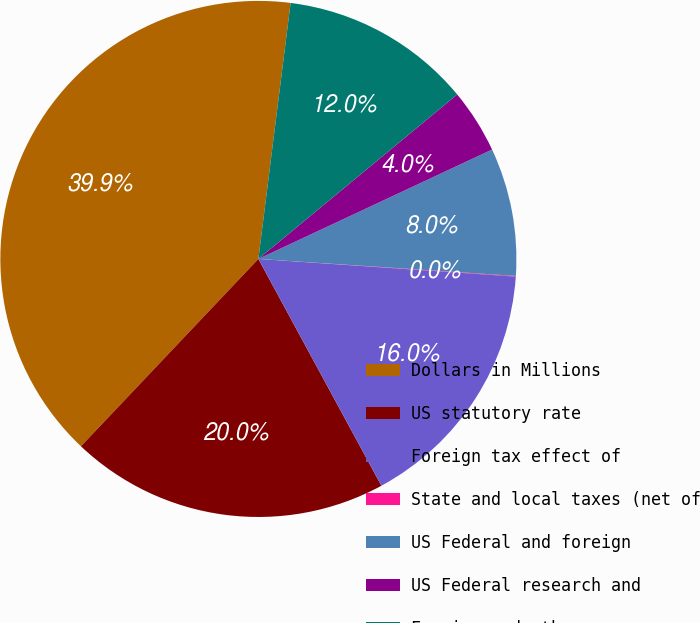Convert chart. <chart><loc_0><loc_0><loc_500><loc_500><pie_chart><fcel>Dollars in Millions<fcel>US statutory rate<fcel>Foreign tax effect of<fcel>State and local taxes (net of<fcel>US Federal and foreign<fcel>US Federal research and<fcel>Foreign and other<nl><fcel>39.93%<fcel>19.98%<fcel>16.0%<fcel>0.04%<fcel>8.02%<fcel>4.03%<fcel>12.01%<nl></chart> 